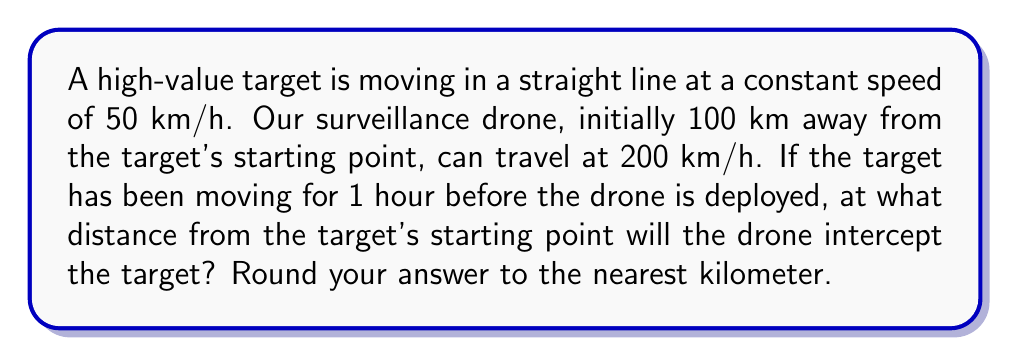Can you solve this math problem? Let's approach this step-by-step:

1) First, let's define our variables:
   $d$ = distance of interception from the target's starting point
   $t$ = time taken by the drone to reach the interception point

2) When the drone is deployed, the target has already traveled for 1 hour. So its position at drone deployment is:
   $50 \text{ km/h} \times 1 \text{ h} = 50 \text{ km}$

3) We can set up two equations based on the distances traveled:

   For the target: $d = 50 + 50t$
   For the drone: $d = 200t$

4) At the interception point, these distances are equal, so:
   $50 + 50t = 200t$

5) Solve this equation:
   $50 = 150t$
   $t = \frac{50}{150} = \frac{1}{3} \text{ hours}$

6) Now we can find the distance by substituting this time into either equation:
   $d = 50 + 50(\frac{1}{3}) = 50 + 16.67 = 66.67 \text{ km}$

7) Rounding to the nearest kilometer:
   $d \approx 67 \text{ km}$
Answer: 67 km 